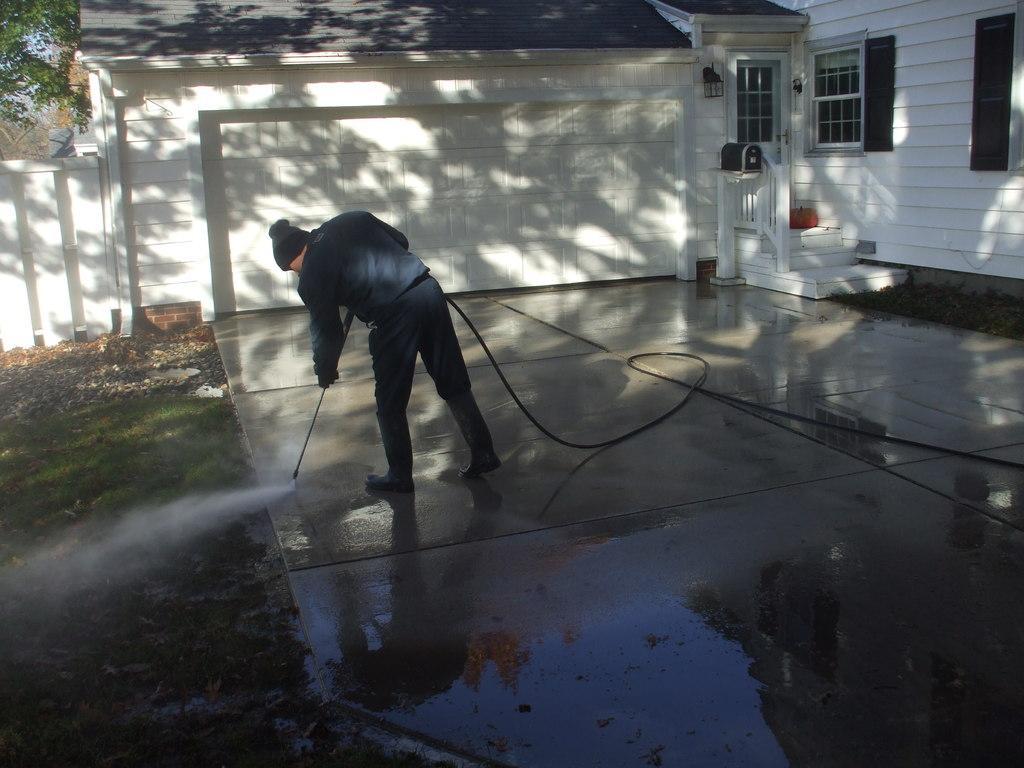Can you describe this image briefly? A person is standing wearing a beanie and holding a pipe. He is watering the grass present at the left. There is a tree at the left back. There is a white building behind him. It has railing, stairs and windows at the right back. 